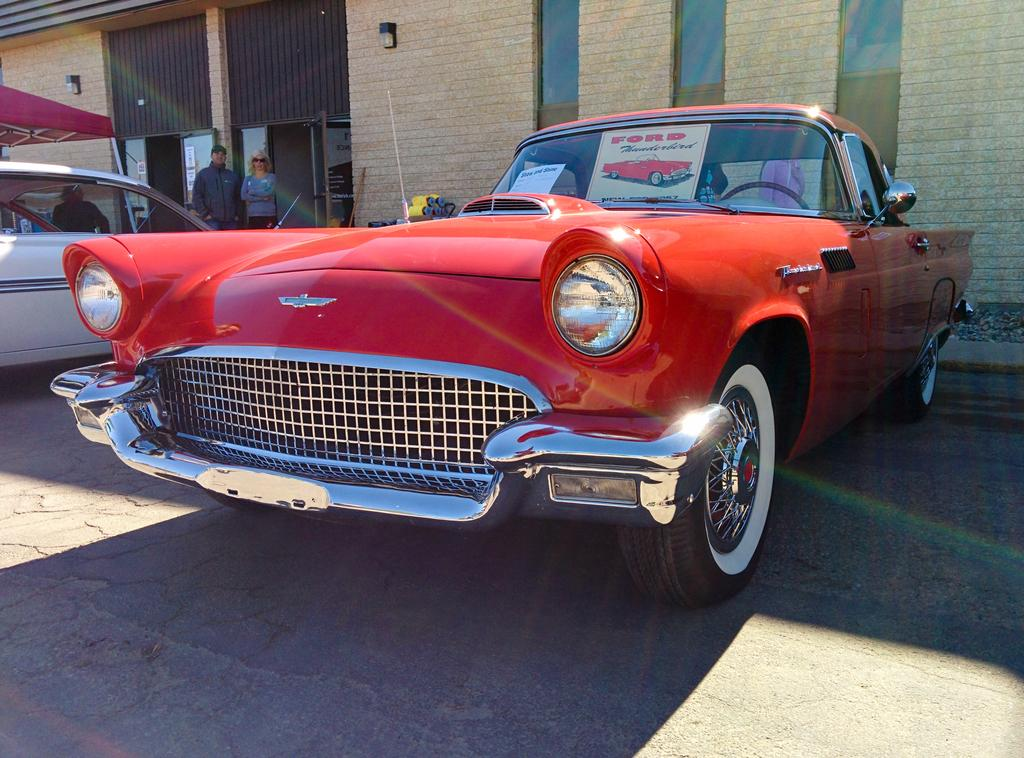What is the main subject in the center of the image? There is a car in the center of the image. Where is the car located? The car is on the road. What else can be seen on the left side of the image? There is another car and two persons on the left side of the image. What can be seen in the background of the image? There is a wall in the background of the image. What type of string is being used by the monkey to create the car in the image? There is no monkey or string present in the image; it features a car on the road and another car with two persons on the left side. 